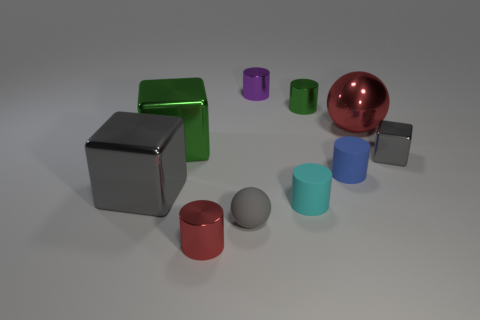What number of rubber things are either small purple things or small red cylinders?
Offer a very short reply. 0. There is a rubber thing that is left of the cyan thing; is it the same shape as the big green metallic object?
Offer a very short reply. No. Are there more cyan rubber cylinders in front of the small blue cylinder than cylinders?
Your response must be concise. No. How many metal objects are both left of the large green shiny object and right of the small gray ball?
Your answer should be compact. 0. There is a cube that is right of the green thing that is on the right side of the small red thing; what is its color?
Ensure brevity in your answer.  Gray. How many small rubber things have the same color as the small shiny block?
Your response must be concise. 1. Is the color of the matte ball the same as the matte object that is behind the cyan cylinder?
Make the answer very short. No. Is the number of large gray objects less than the number of tiny red rubber balls?
Offer a terse response. No. Are there more large red things behind the metal sphere than gray balls that are behind the blue rubber cylinder?
Ensure brevity in your answer.  No. Does the blue cylinder have the same material as the green cube?
Make the answer very short. No. 